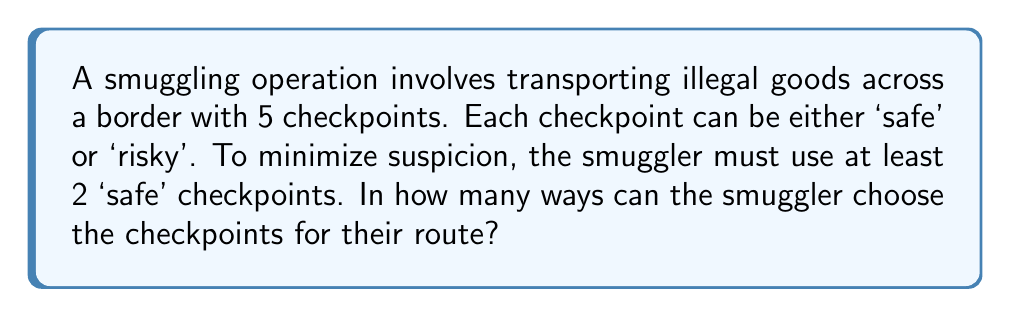Could you help me with this problem? Let's approach this step-by-step:

1) We have 5 checkpoints in total, and each can be either 'safe' or 'risky'.

2) The smuggler must use at least 2 'safe' checkpoints. This means we can have:
   - 2 safe checkpoints and 3 risky ones
   - 3 safe checkpoints and 2 risky ones
   - 4 safe checkpoints and 1 risky one
   - All 5 safe checkpoints

3) Let's calculate each case:

   a) 2 safe, 3 risky: 
      We need to choose 2 out of 5 for safe checkpoints. This can be done in $\binom{5}{2}$ ways.
      $$\binom{5}{2} = \frac{5!}{2!(5-2)!} = \frac{5 \cdot 4}{2 \cdot 1} = 10$$

   b) 3 safe, 2 risky:
      We need to choose 3 out of 5 for safe checkpoints. This can be done in $\binom{5}{3}$ ways.
      $$\binom{5}{3} = \frac{5!}{3!(5-3)!} = \frac{5 \cdot 4 \cdot 3}{3 \cdot 2 \cdot 1} = 10$$

   c) 4 safe, 1 risky:
      We need to choose 4 out of 5 for safe checkpoints. This can be done in $\binom{5}{4}$ ways.
      $$\binom{5}{4} = \frac{5!}{4!(5-4)!} = \frac{5}{1} = 5$$

   d) All 5 safe:
      There's only 1 way to choose all 5 checkpoints as safe.

4) The total number of ways is the sum of all these possibilities:
   $$10 + 10 + 5 + 1 = 26$$

Therefore, there are 26 different ways to choose the checkpoints for the smuggling route.
Answer: 26 ways 